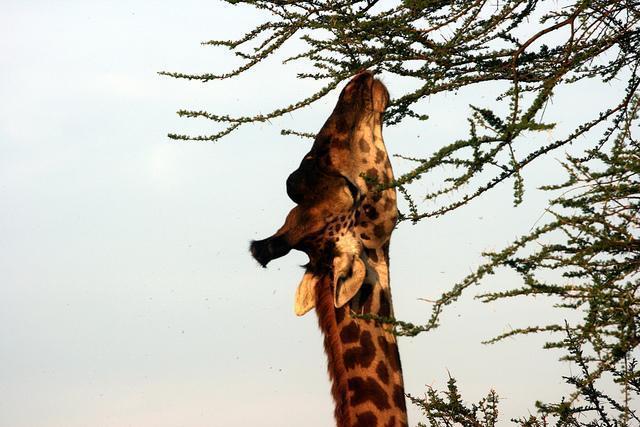How many giraffes are in the photo?
Give a very brief answer. 1. 